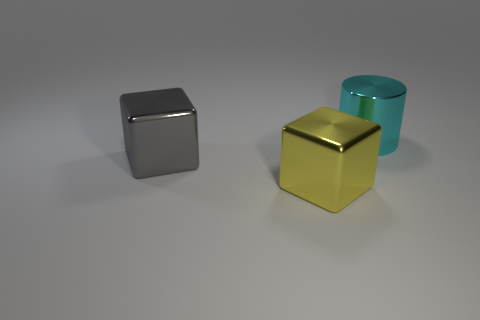Are the yellow cube and the big cyan cylinder behind the gray shiny thing made of the same material?
Your answer should be compact. Yes. Is there a gray cube made of the same material as the yellow cube?
Make the answer very short. Yes. How many things are blocks that are behind the yellow thing or big cubes that are to the left of the yellow cube?
Offer a very short reply. 1. There is a large cyan thing; does it have the same shape as the thing in front of the large gray cube?
Your response must be concise. No. How many other objects are there of the same shape as the big gray object?
Keep it short and to the point. 1. How many objects are large gray metal cubes or big yellow things?
Your answer should be compact. 2. Is there any other thing that has the same size as the yellow block?
Offer a very short reply. Yes. The object in front of the cube that is to the left of the big yellow object is what shape?
Your response must be concise. Cube. Is the number of metal balls less than the number of big cylinders?
Keep it short and to the point. Yes. There is a metal thing that is right of the big gray cube and in front of the cyan thing; what is its size?
Your response must be concise. Large. 